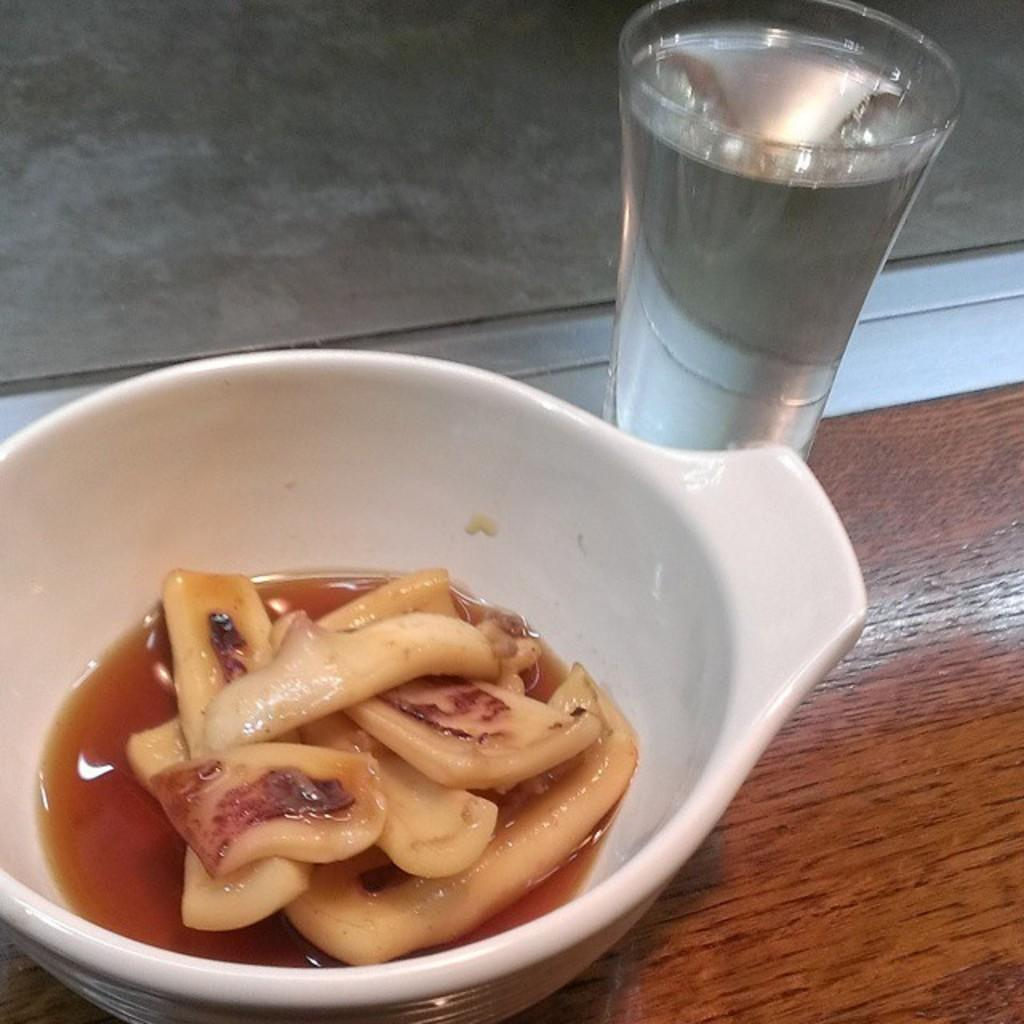What is in the bowl that is visible in the image? There is food present in the bowl. Besides the bowl, what other items can be seen in the image? There is a glass of drink visible in the image. What type of mist can be seen surrounding the food in the bowl? There is no mist present in the image; it only features a bowl with food and a glass of drink. 